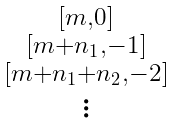Convert formula to latex. <formula><loc_0><loc_0><loc_500><loc_500>\begin{smallmatrix} [ m , 0 ] \\ [ m + n _ { 1 } , - 1 ] \\ [ m + n _ { 1 } + n _ { 2 } , - 2 ] \\ \vdots \end{smallmatrix}</formula> 